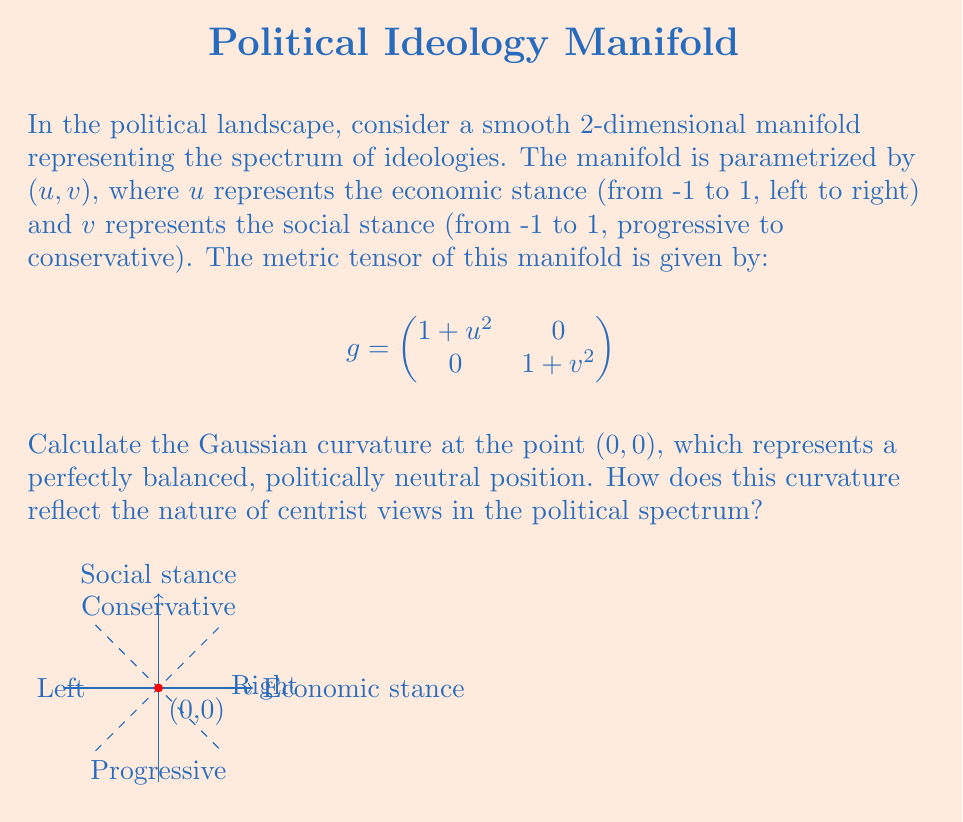Help me with this question. To calculate the Gaussian curvature of this manifold, we'll follow these steps:

1) The Gaussian curvature $K$ is given by:

   $$K = \frac{R_{1212}}{det(g)}$$

   where $R_{1212}$ is a component of the Riemann curvature tensor.

2) For a 2D manifold with metric $g_{ij}$, $R_{1212}$ can be calculated as:

   $$R_{1212} = \frac{1}{2}(\partial_1\partial_1 g_{22} + \partial_2\partial_2 g_{11} - \partial_1\partial_2 g_{12} - \partial_2\partial_1 g_{21})$$

   $- \frac{1}{4}g^{ab}(\partial_1 g_{a2}\partial_2 g_{1b} - \partial_1 g_{ab}\partial_2 g_{12})$

3) In our case:
   $g_{11} = 1+u^2$, $g_{22} = 1+v^2$, $g_{12} = g_{21} = 0$

4) Calculating the partial derivatives:
   $\partial_1\partial_1 g_{22} = 0$
   $\partial_2\partial_2 g_{11} = 0$
   $\partial_1\partial_2 g_{12} = \partial_2\partial_1 g_{21} = 0$

5) The inverse metric $g^{ab}$ is:

   $$g^{ab} = \begin{pmatrix}
   \frac{1}{1+u^2} & 0 \\
   0 & \frac{1}{1+v^2}
   \end{pmatrix}$$

6) Calculating the remaining terms:
   $\partial_1 g_{a2}\partial_2 g_{1b} = 0$ (since $g_{12} = g_{21} = 0$)
   $\partial_1 g_{ab}\partial_2 g_{12} = 0$ (since $g_{12} = 0$)

7) Therefore, $R_{1212} = 0$

8) The determinant of $g$ at $(0,0)$ is:
   $det(g) = (1+0^2)(1+0^2) = 1$

9) Thus, the Gaussian curvature at $(0,0)$ is:
   $$K = \frac{R_{1212}}{det(g)} = \frac{0}{1} = 0$$

The zero curvature at the politically neutral point $(0,0)$ indicates that the manifold is locally flat at this point. This flatness suggests that centrist views in the political spectrum offer a balanced perspective where small deviations in any direction result in minimal changes, reflecting the stability and moderation of centrist positions.
Answer: $K = 0$ 